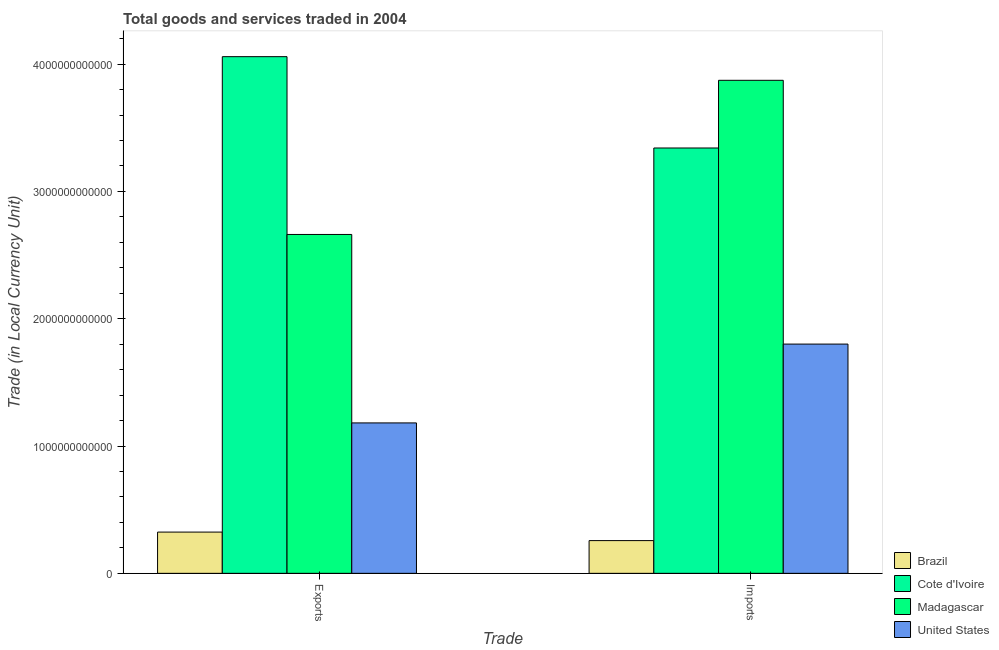How many different coloured bars are there?
Offer a terse response. 4. How many groups of bars are there?
Offer a terse response. 2. What is the label of the 1st group of bars from the left?
Keep it short and to the point. Exports. What is the export of goods and services in Brazil?
Your answer should be compact. 3.24e+11. Across all countries, what is the maximum imports of goods and services?
Offer a terse response. 3.87e+12. Across all countries, what is the minimum imports of goods and services?
Your answer should be compact. 2.57e+11. In which country was the imports of goods and services maximum?
Your answer should be compact. Madagascar. In which country was the imports of goods and services minimum?
Provide a short and direct response. Brazil. What is the total export of goods and services in the graph?
Offer a very short reply. 8.23e+12. What is the difference between the imports of goods and services in Cote d'Ivoire and that in United States?
Make the answer very short. 1.54e+12. What is the difference between the export of goods and services in Madagascar and the imports of goods and services in United States?
Offer a very short reply. 8.61e+11. What is the average imports of goods and services per country?
Offer a very short reply. 2.32e+12. What is the difference between the imports of goods and services and export of goods and services in Cote d'Ivoire?
Provide a short and direct response. -7.17e+11. What is the ratio of the imports of goods and services in Cote d'Ivoire to that in United States?
Offer a very short reply. 1.86. What does the 2nd bar from the left in Exports represents?
Your response must be concise. Cote d'Ivoire. What does the 2nd bar from the right in Exports represents?
Make the answer very short. Madagascar. How many bars are there?
Your answer should be very brief. 8. What is the difference between two consecutive major ticks on the Y-axis?
Offer a terse response. 1.00e+12. Where does the legend appear in the graph?
Make the answer very short. Bottom right. How are the legend labels stacked?
Keep it short and to the point. Vertical. What is the title of the graph?
Ensure brevity in your answer.  Total goods and services traded in 2004. Does "Cambodia" appear as one of the legend labels in the graph?
Your response must be concise. No. What is the label or title of the X-axis?
Make the answer very short. Trade. What is the label or title of the Y-axis?
Ensure brevity in your answer.  Trade (in Local Currency Unit). What is the Trade (in Local Currency Unit) of Brazil in Exports?
Provide a succinct answer. 3.24e+11. What is the Trade (in Local Currency Unit) in Cote d'Ivoire in Exports?
Your answer should be very brief. 4.06e+12. What is the Trade (in Local Currency Unit) of Madagascar in Exports?
Your response must be concise. 2.66e+12. What is the Trade (in Local Currency Unit) of United States in Exports?
Your answer should be compact. 1.18e+12. What is the Trade (in Local Currency Unit) of Brazil in Imports?
Ensure brevity in your answer.  2.57e+11. What is the Trade (in Local Currency Unit) in Cote d'Ivoire in Imports?
Give a very brief answer. 3.34e+12. What is the Trade (in Local Currency Unit) of Madagascar in Imports?
Make the answer very short. 3.87e+12. What is the Trade (in Local Currency Unit) in United States in Imports?
Ensure brevity in your answer.  1.80e+12. Across all Trade, what is the maximum Trade (in Local Currency Unit) of Brazil?
Give a very brief answer. 3.24e+11. Across all Trade, what is the maximum Trade (in Local Currency Unit) in Cote d'Ivoire?
Your answer should be compact. 4.06e+12. Across all Trade, what is the maximum Trade (in Local Currency Unit) of Madagascar?
Offer a terse response. 3.87e+12. Across all Trade, what is the maximum Trade (in Local Currency Unit) in United States?
Keep it short and to the point. 1.80e+12. Across all Trade, what is the minimum Trade (in Local Currency Unit) in Brazil?
Keep it short and to the point. 2.57e+11. Across all Trade, what is the minimum Trade (in Local Currency Unit) of Cote d'Ivoire?
Provide a short and direct response. 3.34e+12. Across all Trade, what is the minimum Trade (in Local Currency Unit) of Madagascar?
Offer a very short reply. 2.66e+12. Across all Trade, what is the minimum Trade (in Local Currency Unit) of United States?
Your response must be concise. 1.18e+12. What is the total Trade (in Local Currency Unit) in Brazil in the graph?
Give a very brief answer. 5.81e+11. What is the total Trade (in Local Currency Unit) of Cote d'Ivoire in the graph?
Your answer should be compact. 7.40e+12. What is the total Trade (in Local Currency Unit) of Madagascar in the graph?
Offer a terse response. 6.53e+12. What is the total Trade (in Local Currency Unit) of United States in the graph?
Provide a short and direct response. 2.98e+12. What is the difference between the Trade (in Local Currency Unit) in Brazil in Exports and that in Imports?
Your answer should be compact. 6.68e+1. What is the difference between the Trade (in Local Currency Unit) of Cote d'Ivoire in Exports and that in Imports?
Offer a very short reply. 7.17e+11. What is the difference between the Trade (in Local Currency Unit) in Madagascar in Exports and that in Imports?
Give a very brief answer. -1.21e+12. What is the difference between the Trade (in Local Currency Unit) in United States in Exports and that in Imports?
Your answer should be compact. -6.19e+11. What is the difference between the Trade (in Local Currency Unit) of Brazil in Exports and the Trade (in Local Currency Unit) of Cote d'Ivoire in Imports?
Offer a very short reply. -3.02e+12. What is the difference between the Trade (in Local Currency Unit) of Brazil in Exports and the Trade (in Local Currency Unit) of Madagascar in Imports?
Offer a terse response. -3.55e+12. What is the difference between the Trade (in Local Currency Unit) in Brazil in Exports and the Trade (in Local Currency Unit) in United States in Imports?
Provide a succinct answer. -1.48e+12. What is the difference between the Trade (in Local Currency Unit) of Cote d'Ivoire in Exports and the Trade (in Local Currency Unit) of Madagascar in Imports?
Make the answer very short. 1.86e+11. What is the difference between the Trade (in Local Currency Unit) in Cote d'Ivoire in Exports and the Trade (in Local Currency Unit) in United States in Imports?
Offer a terse response. 2.26e+12. What is the difference between the Trade (in Local Currency Unit) in Madagascar in Exports and the Trade (in Local Currency Unit) in United States in Imports?
Give a very brief answer. 8.61e+11. What is the average Trade (in Local Currency Unit) in Brazil per Trade?
Give a very brief answer. 2.91e+11. What is the average Trade (in Local Currency Unit) of Cote d'Ivoire per Trade?
Give a very brief answer. 3.70e+12. What is the average Trade (in Local Currency Unit) of Madagascar per Trade?
Ensure brevity in your answer.  3.27e+12. What is the average Trade (in Local Currency Unit) of United States per Trade?
Give a very brief answer. 1.49e+12. What is the difference between the Trade (in Local Currency Unit) of Brazil and Trade (in Local Currency Unit) of Cote d'Ivoire in Exports?
Your answer should be compact. -3.73e+12. What is the difference between the Trade (in Local Currency Unit) in Brazil and Trade (in Local Currency Unit) in Madagascar in Exports?
Keep it short and to the point. -2.34e+12. What is the difference between the Trade (in Local Currency Unit) in Brazil and Trade (in Local Currency Unit) in United States in Exports?
Your response must be concise. -8.58e+11. What is the difference between the Trade (in Local Currency Unit) in Cote d'Ivoire and Trade (in Local Currency Unit) in Madagascar in Exports?
Ensure brevity in your answer.  1.40e+12. What is the difference between the Trade (in Local Currency Unit) in Cote d'Ivoire and Trade (in Local Currency Unit) in United States in Exports?
Make the answer very short. 2.88e+12. What is the difference between the Trade (in Local Currency Unit) of Madagascar and Trade (in Local Currency Unit) of United States in Exports?
Ensure brevity in your answer.  1.48e+12. What is the difference between the Trade (in Local Currency Unit) in Brazil and Trade (in Local Currency Unit) in Cote d'Ivoire in Imports?
Keep it short and to the point. -3.08e+12. What is the difference between the Trade (in Local Currency Unit) in Brazil and Trade (in Local Currency Unit) in Madagascar in Imports?
Offer a terse response. -3.62e+12. What is the difference between the Trade (in Local Currency Unit) of Brazil and Trade (in Local Currency Unit) of United States in Imports?
Your answer should be compact. -1.54e+12. What is the difference between the Trade (in Local Currency Unit) in Cote d'Ivoire and Trade (in Local Currency Unit) in Madagascar in Imports?
Offer a terse response. -5.32e+11. What is the difference between the Trade (in Local Currency Unit) in Cote d'Ivoire and Trade (in Local Currency Unit) in United States in Imports?
Make the answer very short. 1.54e+12. What is the difference between the Trade (in Local Currency Unit) in Madagascar and Trade (in Local Currency Unit) in United States in Imports?
Make the answer very short. 2.07e+12. What is the ratio of the Trade (in Local Currency Unit) in Brazil in Exports to that in Imports?
Offer a terse response. 1.26. What is the ratio of the Trade (in Local Currency Unit) in Cote d'Ivoire in Exports to that in Imports?
Your response must be concise. 1.21. What is the ratio of the Trade (in Local Currency Unit) in Madagascar in Exports to that in Imports?
Your answer should be very brief. 0.69. What is the ratio of the Trade (in Local Currency Unit) of United States in Exports to that in Imports?
Give a very brief answer. 0.66. What is the difference between the highest and the second highest Trade (in Local Currency Unit) in Brazil?
Offer a terse response. 6.68e+1. What is the difference between the highest and the second highest Trade (in Local Currency Unit) of Cote d'Ivoire?
Your response must be concise. 7.17e+11. What is the difference between the highest and the second highest Trade (in Local Currency Unit) of Madagascar?
Give a very brief answer. 1.21e+12. What is the difference between the highest and the second highest Trade (in Local Currency Unit) of United States?
Your answer should be very brief. 6.19e+11. What is the difference between the highest and the lowest Trade (in Local Currency Unit) of Brazil?
Keep it short and to the point. 6.68e+1. What is the difference between the highest and the lowest Trade (in Local Currency Unit) in Cote d'Ivoire?
Offer a very short reply. 7.17e+11. What is the difference between the highest and the lowest Trade (in Local Currency Unit) of Madagascar?
Make the answer very short. 1.21e+12. What is the difference between the highest and the lowest Trade (in Local Currency Unit) of United States?
Make the answer very short. 6.19e+11. 